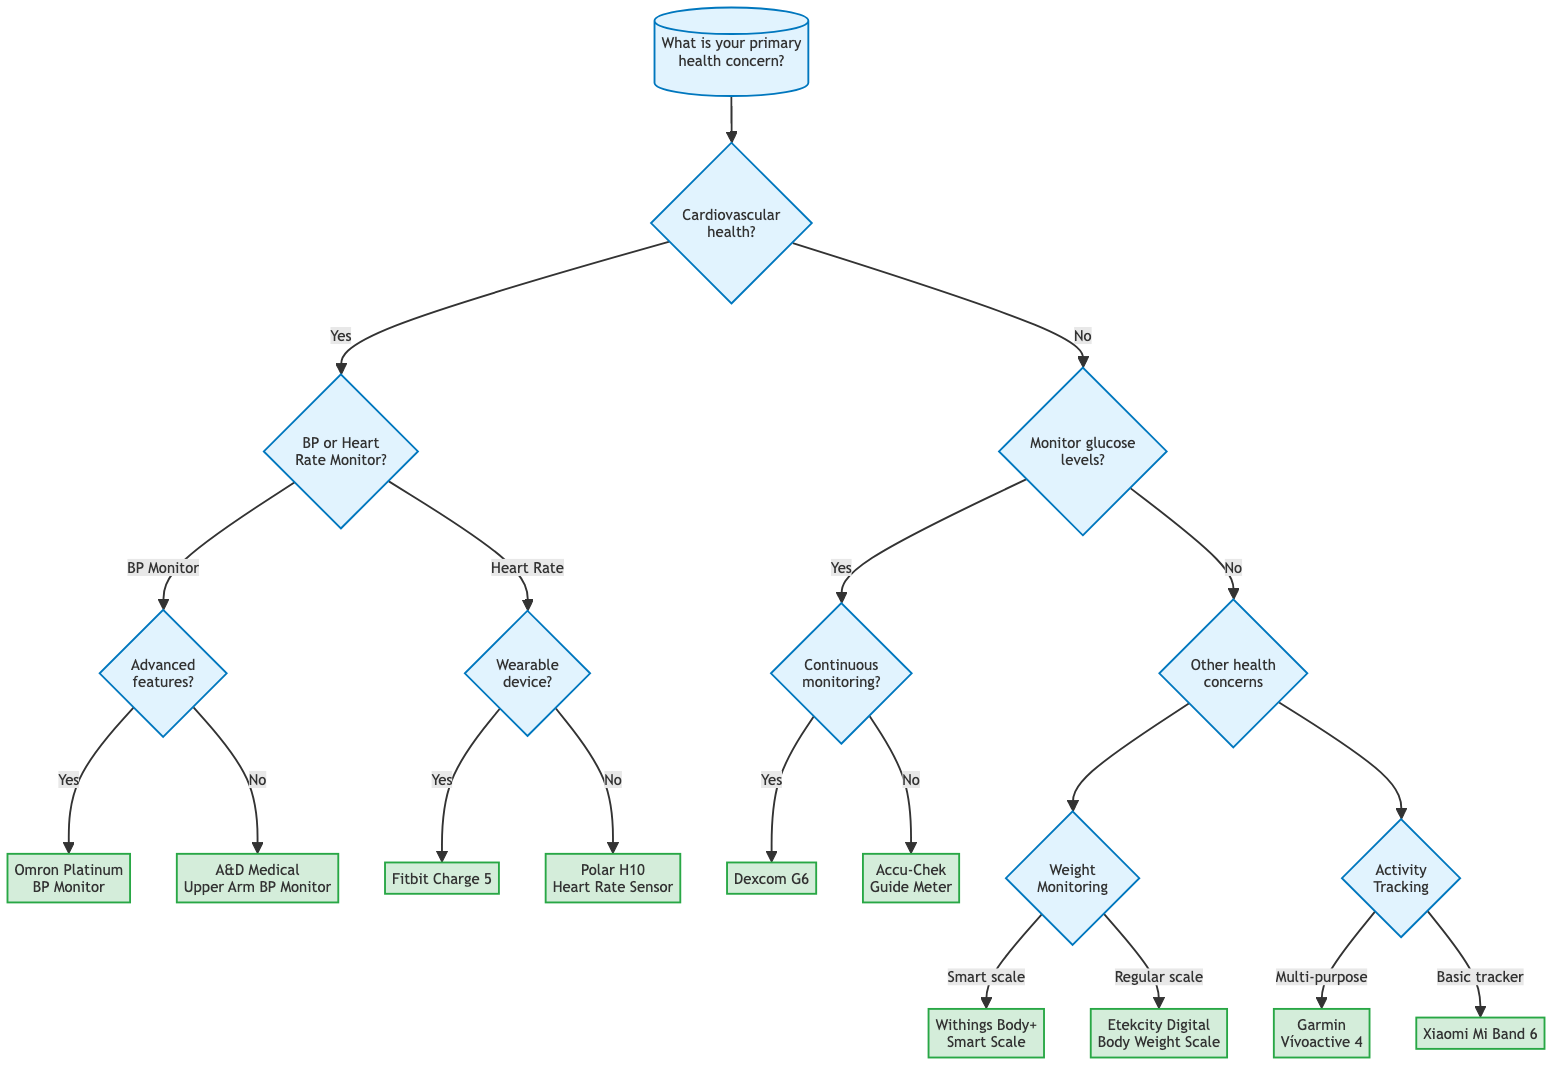What is the primary health concern to start the decision tree? The root question in the decision tree is "What is your primary health concern?" This is the first question that guides the decision-making process.
Answer: What is your primary health concern? How many options are available for monitoring cardiovascular health? The node "Do you need to monitor your cardiovascular health?" leads to two options for cardiovascular health monitoring: "Blood Pressure Monitor" and "Heart Rate Monitor." Therefore, there are two options available.
Answer: Two options What device is suggested if you need a Blood Pressure Monitor with advanced features? The flow from the "Blood Pressure Monitor" option leads to the question about advanced features. If the answer is "yes," the recommended device is the "Omron Platinum Blood Pressure Monitor."
Answer: Omron Platinum Blood Pressure Monitor What is the outcome if someone prefers a wearable device for heart rate monitoring? The diagram shows that upon selecting "Heart Rate Monitor" and answering "yes" to preferring a wearable device, the flow leads to the suggestion of the "Fitbit Charge 5."
Answer: Fitbit Charge 5 If a person does not need any cardiovascular health monitoring or glucose monitoring, what is the next area of concern? The decision tree leads to the node titled "Other health concerns," indicating a shift to addressing additional health-related issues after ruling out cardiovascular and glucose issues.
Answer: Other health concerns What will you get if you need to monitor your glucose levels but not continuously? The decision tree shows that if the answer to "Are you looking for a continuous glucose monitoring system?" is "no," the outcome is the "Accu-Chek Guide Meter."
Answer: Accu-Chek Guide Meter What smart scale is recommended for those wanting a smart weight monitoring device? Starting from the "Weight Monitoring" option, if the answer to "Do you prefer a smart scale?" is "yes," the device suggested is the "Withings Body+ Smart Scale."
Answer: Withings Body+ Smart Scale What two options are provided for activity tracking? Under "Activity Tracking," the decision tree offers two options: "Garmin Vívoactive 4" for a multi-purpose tracker and "Xiaomi Mi Band 6" for a basic tracker, leading to a total of two distinct options.
Answer: Garmin Vívoactive 4 and Xiaomi Mi Band 6 If someone answers "no" to monitoring their cardiovascular health, how many branches extend from that decision? The decision tree branches into two options: one for monitoring glucose levels and another for other health concerns. This results in two branches stemming from the "no" response for cardiovascular health.
Answer: Two branches 